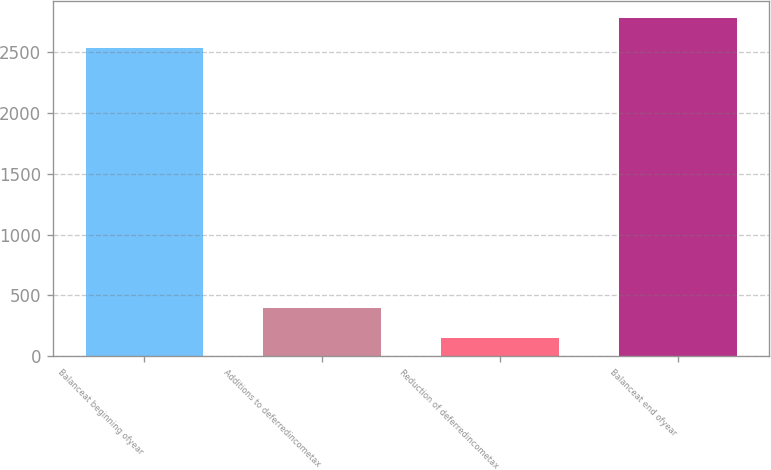<chart> <loc_0><loc_0><loc_500><loc_500><bar_chart><fcel>Balanceat beginning ofyear<fcel>Additions to deferredincometax<fcel>Reduction of deferredincometax<fcel>Balanceat end ofyear<nl><fcel>2540<fcel>392.4<fcel>151<fcel>2781.4<nl></chart> 